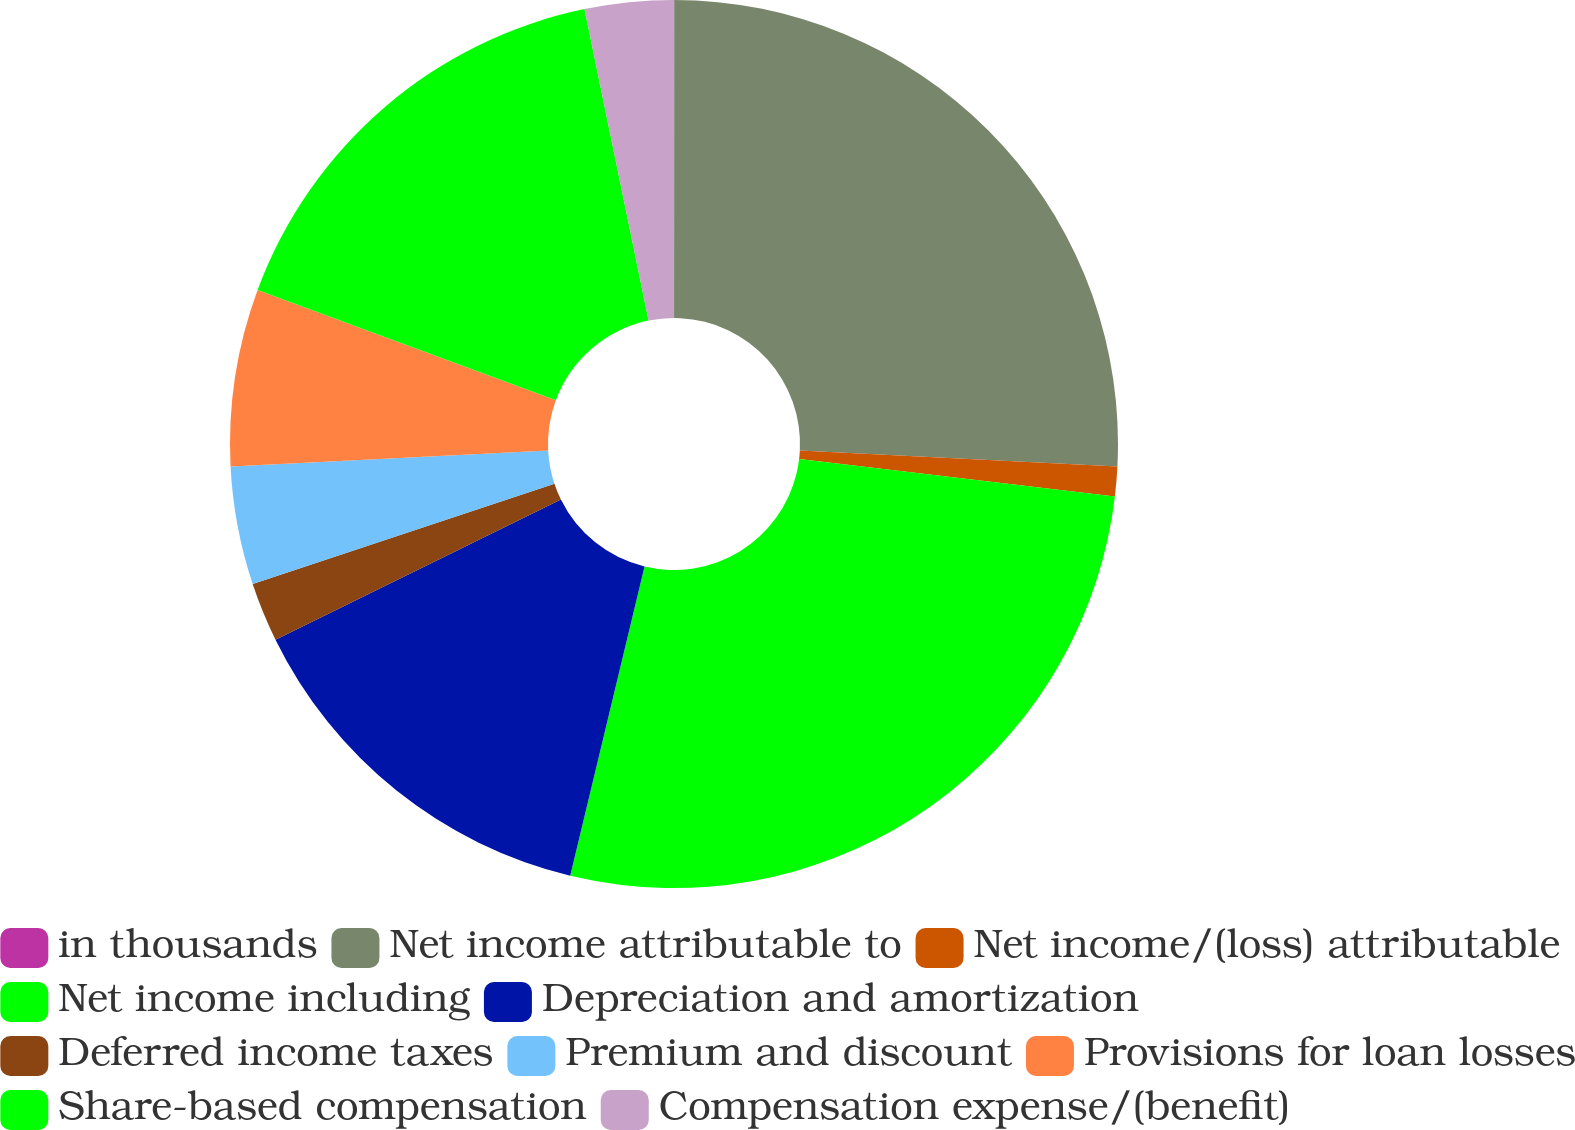Convert chart. <chart><loc_0><loc_0><loc_500><loc_500><pie_chart><fcel>in thousands<fcel>Net income attributable to<fcel>Net income/(loss) attributable<fcel>Net income including<fcel>Depreciation and amortization<fcel>Deferred income taxes<fcel>Premium and discount<fcel>Provisions for loan losses<fcel>Share-based compensation<fcel>Compensation expense/(benefit)<nl><fcel>0.01%<fcel>25.8%<fcel>1.08%<fcel>26.87%<fcel>13.98%<fcel>2.16%<fcel>4.3%<fcel>6.45%<fcel>16.13%<fcel>3.23%<nl></chart> 